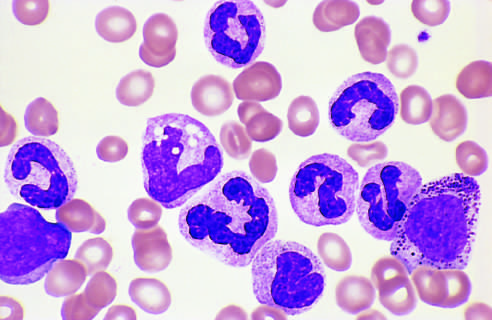what are present?
Answer the question using a single word or phrase. Granulocytic forms at various stages of differentiation 